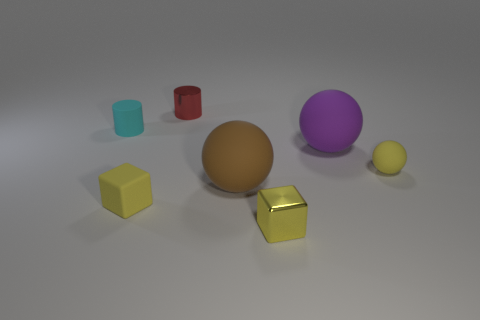There is a tiny rubber thing that is the same color as the matte block; what shape is it?
Offer a terse response. Sphere. Is the color of the tiny matte cube the same as the tiny metal cube?
Your response must be concise. Yes. What number of small matte spheres are the same color as the metal block?
Give a very brief answer. 1. There is a yellow block that is the same material as the red thing; what size is it?
Offer a very short reply. Small. What is the material of the sphere that is the same size as the red cylinder?
Provide a succinct answer. Rubber. There is a red metal object behind the purple thing; is its size the same as the large purple sphere?
Your answer should be compact. No. What number of blocks are purple things or yellow things?
Your answer should be very brief. 2. What is the material of the small red cylinder behind the shiny cube?
Your answer should be compact. Metal. Is the number of yellow blocks less than the number of tiny matte objects?
Your answer should be very brief. Yes. There is a matte thing that is both behind the yellow matte sphere and on the right side of the cyan matte thing; what is its size?
Your answer should be very brief. Large. 